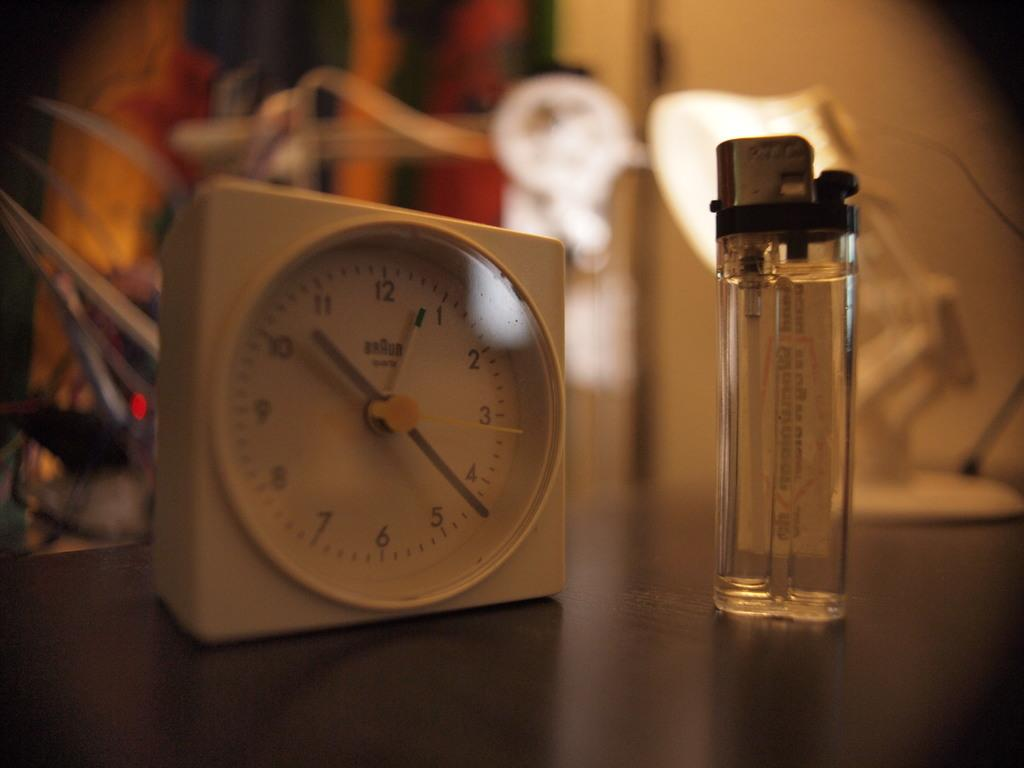<image>
Relay a brief, clear account of the picture shown. A white clock with silver hands has the time of 10:22. 